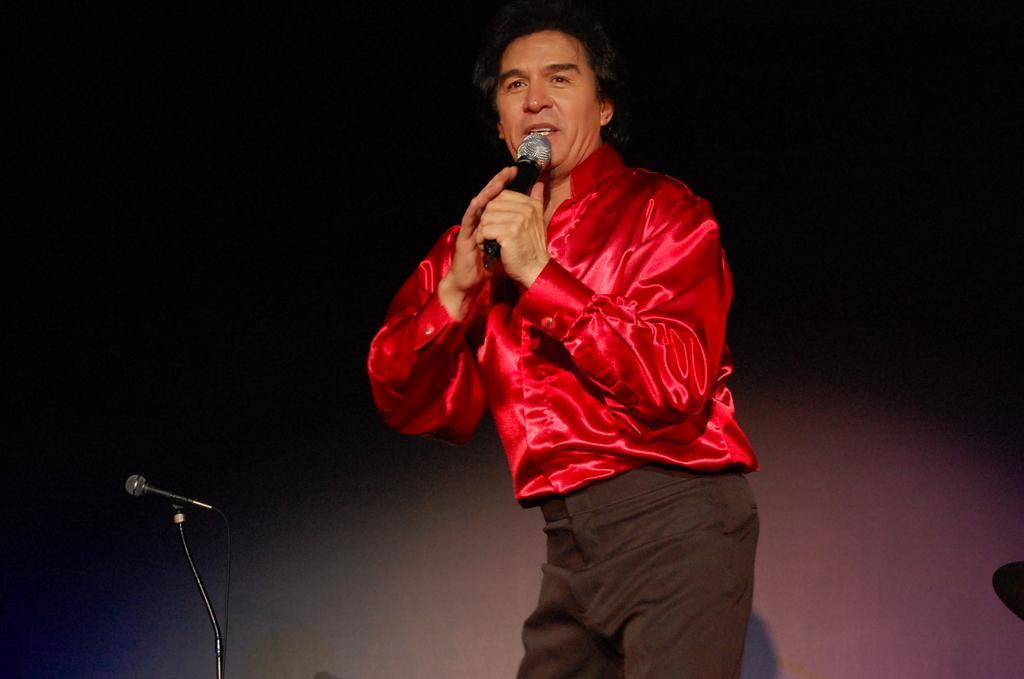Can you describe this image briefly? In this image I can see a man wearing red color shirt, standing and holding a mike in his hand. It seems like he is also singing a song. On the left side there is a mike stand. 